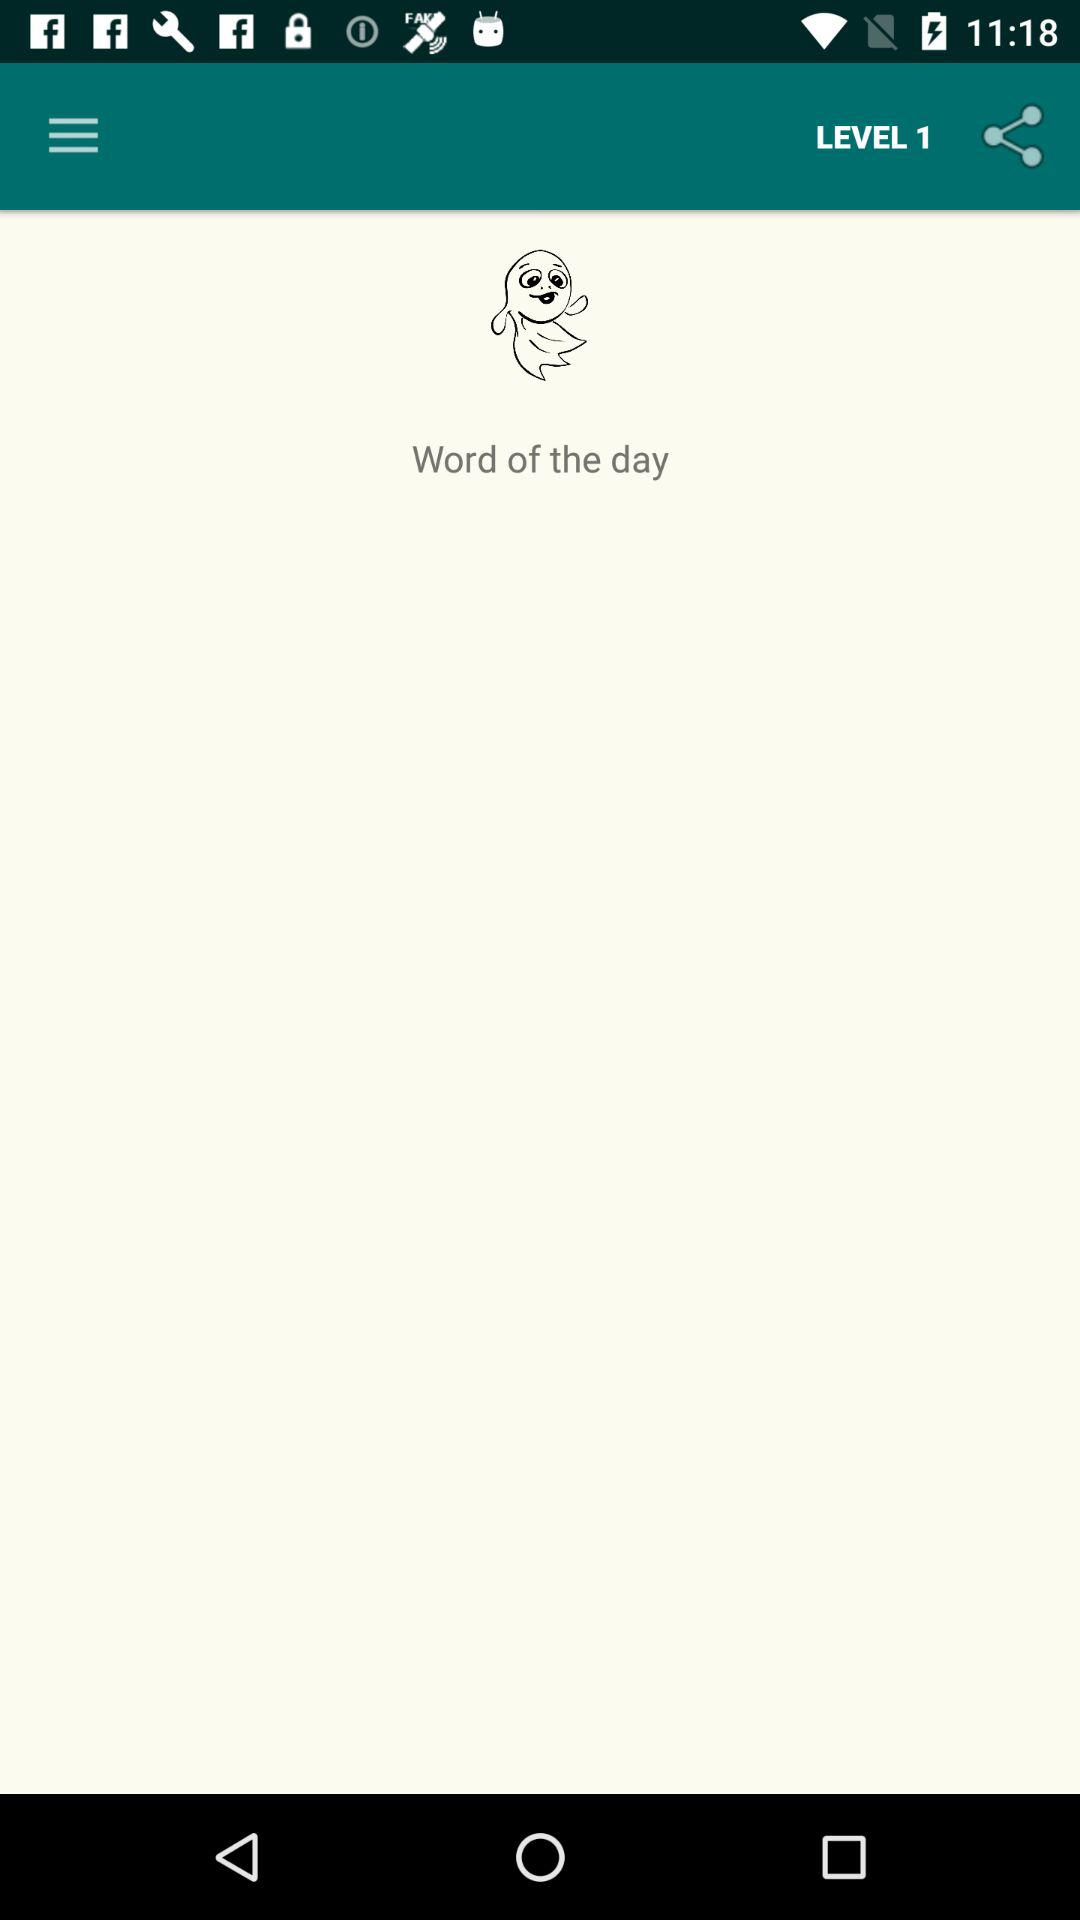What level is this? This is level 1. 